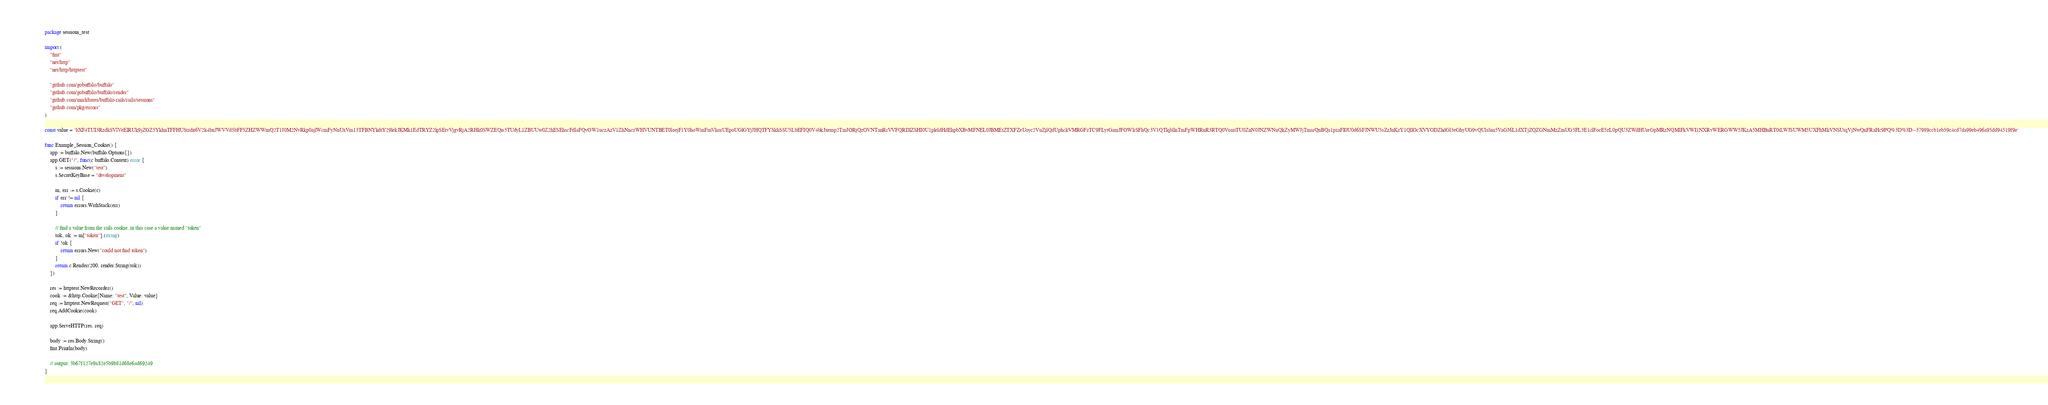<code> <loc_0><loc_0><loc_500><loc_500><_Go_>package sessions_test

import (
	"fmt"
	"net/http"
	"net/http/httptest"

	"github.com/gobuffalo/buffalo"
	"github.com/gobuffalo/buffalo/render"
	"github.com/markbates/buffalo-rails/rails/sessions"
	"github.com/pkg/errors"
)

const value = `bXF4TUI3RzdkSVlVeElRUk9jZGZ5YkhnTFFHUStzdit6V2k4bnJWVVd5bFF5ZHZWWmQ2T1J0M2NvRkp0ajlWcmFyNnUxVm13TFBNYkdtY29lekJKMk1EdTRYZ2lpSEtvVjgvRjA2RHk0SWZEQis5TUdyL1ZBUUw0Z2hESEhscFdlaFQvOW1uczAzV1ZhNnczWHVUNTBET0loejF1Y0hoWmFmVkorUEpoUGlGYjJHQTFYSkhSSU5LbEFIQ0V4bkJxemp2TmJORjQzOVNTanRrVVFQRDlZSHI0U1pleldHdEhpbXBvMFNEL0JBMEtZTXFZeUoyc2VuZjlQdUphckVMRGFzTC9FLytGamJFOWlrSFhQc3V1QTlqbllnTmFpWHRuR3RTQ0VoaitTU0ZnN0JNZWNuQkZyMWJjTmsrQnBQa1pzaFI0U0d6SFJNWU5sZzJnKzY1QllOcXVYODZhdGl3eGhyUG9vQUlsSm5VaGJ6L1dXTjZQZGNmMzZmUG5FL3E1clFocE5zL0pQU3ZWdHUreGpMRzNQMlFkVWI1NXRvWERGWW5JKzA5MHBuRT0tLWJSUWM5UXFhMkVNSUtqVjNwQnFRaHc9PQ%3D%3D--37989ccb1eb59c4cd7da99eb496a95dd94519f9e`

func Example_Session_Cookie() {
	app := buffalo.New(buffalo.Options{})
	app.GET("/", func(c buffalo.Context) error {
		s := sessions.New("test")
		s.SecretKeyBase = "development"

		m, err := s.Cookie(c)
		if err != nil {
			return errors.WithStack(err)
		}

		// find a value from the rails cookie, in this case a value named "token"
		tok, ok := m["token"].(string)
		if !ok {
			return errors.New("could not find token")
		}
		return c.Render(200, render.String(tok))
	})

	res := httptest.NewRecorder()
	cook := &http.Cookie{Name: "test", Value: value}
	req := httptest.NewRequest("GET", "/", nil)
	req.AddCookie(cook)

	app.ServeHTTP(res, req)

	body := res.Body.String()
	fmt.Println(body)

	// output: 3b67f127e9a82e5b9b81d68e64d69249
}
</code> 